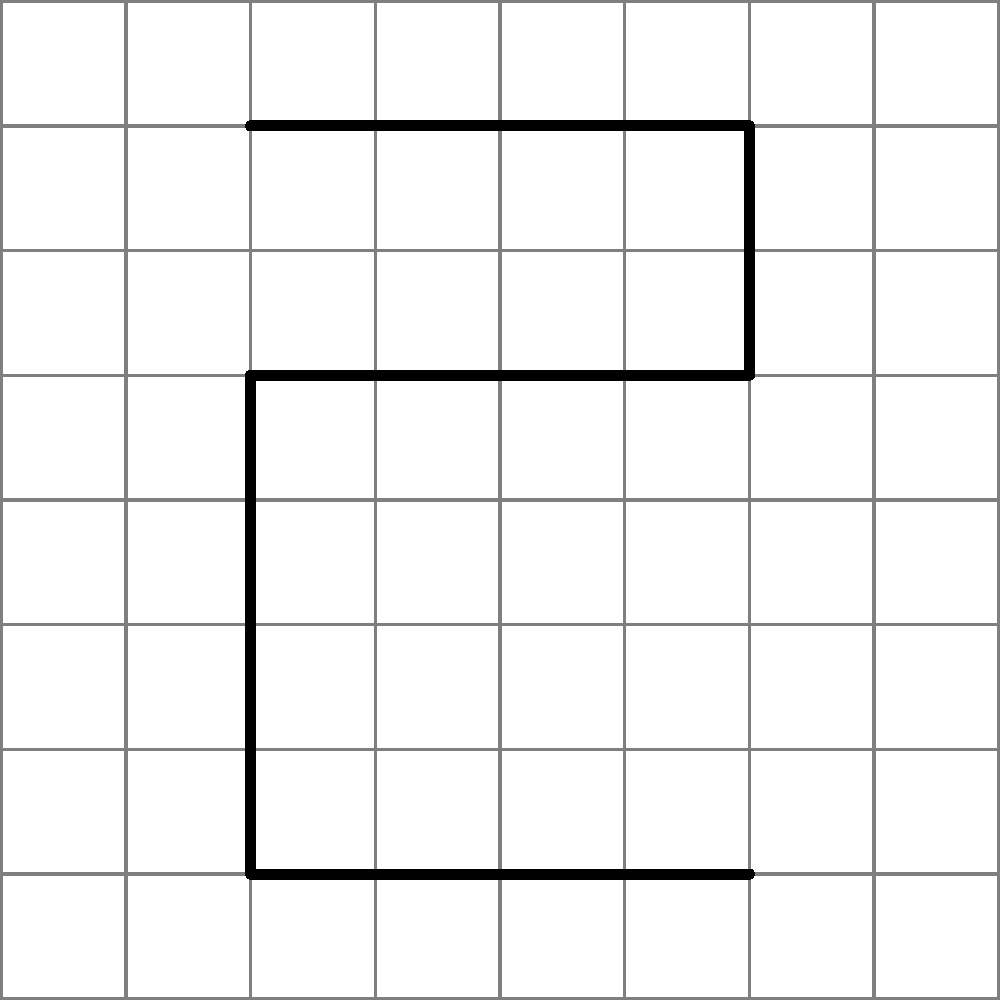In a convolutional neural network for classifying handwritten digits, what is the purpose of the convolutional layer when processing an input image like the one shown above? To understand the purpose of the convolutional layer in classifying handwritten digits, let's break it down step-by-step:

1. Input: The network receives an image of a handwritten digit (like the '5' shown in the diagram) as input.

2. Convolutional Layer:
   a. This layer applies filters (also called kernels) to the input image.
   b. Each filter slides across the image, performing element-wise multiplication and summing the results.
   c. This process creates feature maps that highlight specific patterns or features in the image.

3. Purpose of Convolution:
   a. Feature Extraction: The convolutional layer automatically learns to detect important features such as edges, curves, and shapes that are characteristic of different digits.
   b. Parameter Sharing: The same filter is applied across the entire image, reducing the number of parameters and making the network more efficient.
   c. Translation Invariance: The network can recognize features regardless of their position in the image.

4. Output of Convolutional Layer:
   The output is a set of feature maps, each emphasizing different aspects of the input image.

5. Subsequent Layers:
   These feature maps are then processed by later layers (like pooling and fully connected layers) to make the final classification.

In essence, the convolutional layer's primary purpose is to automatically extract relevant features from the input image, which are crucial for accurately classifying the handwritten digit.
Answer: Feature extraction 